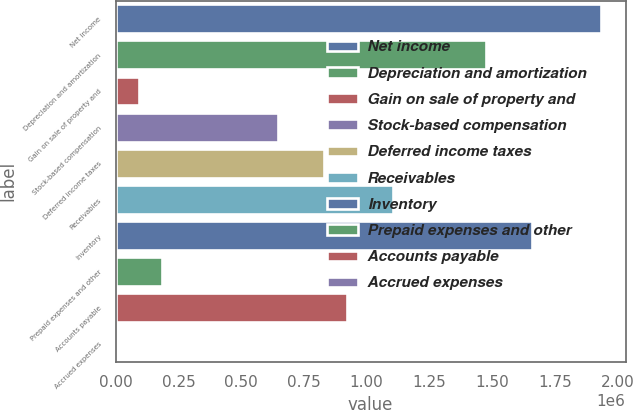Convert chart. <chart><loc_0><loc_0><loc_500><loc_500><bar_chart><fcel>Net income<fcel>Depreciation and amortization<fcel>Gain on sale of property and<fcel>Stock-based compensation<fcel>Deferred income taxes<fcel>Receivables<fcel>Inventory<fcel>Prepaid expenses and other<fcel>Accounts payable<fcel>Accrued expenses<nl><fcel>1.93529e+06<fcel>1.47453e+06<fcel>92271.8<fcel>645177<fcel>829478<fcel>1.10593e+06<fcel>1.65884e+06<fcel>184423<fcel>921629<fcel>121<nl></chart> 